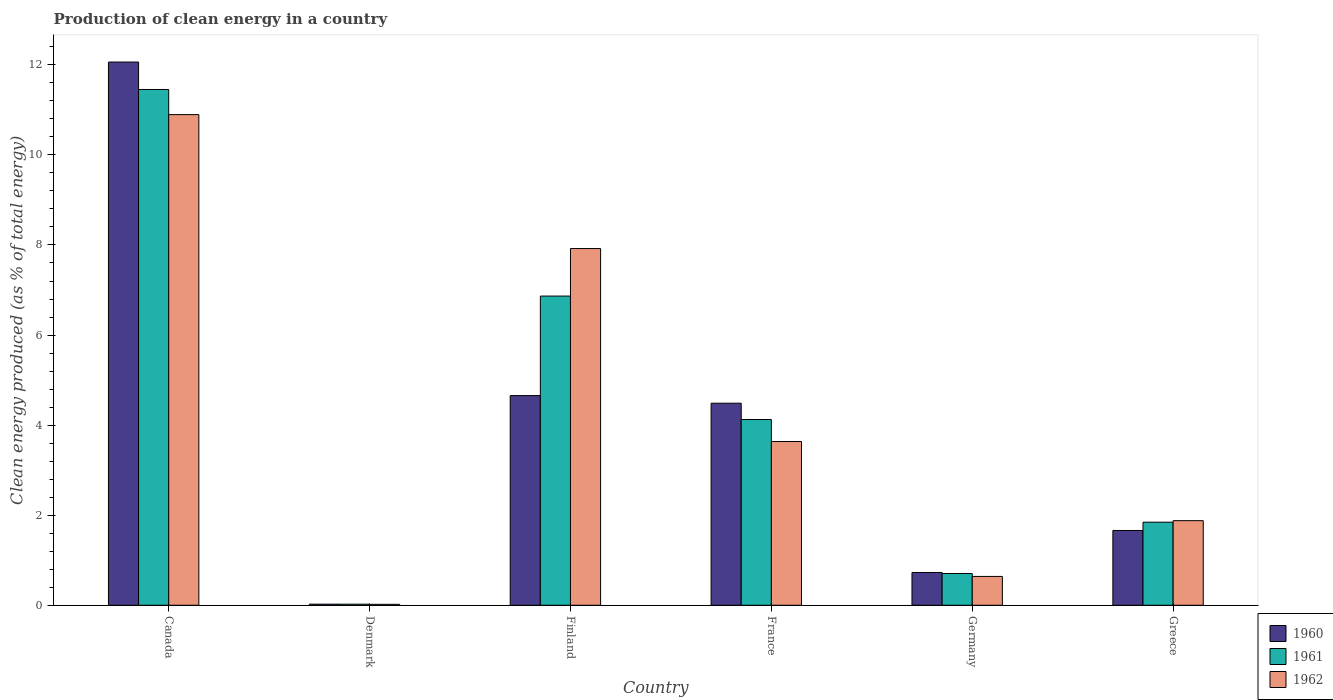How many groups of bars are there?
Ensure brevity in your answer.  6. Are the number of bars on each tick of the X-axis equal?
Keep it short and to the point. Yes. How many bars are there on the 3rd tick from the left?
Provide a short and direct response. 3. What is the percentage of clean energy produced in 1960 in Greece?
Make the answer very short. 1.66. Across all countries, what is the maximum percentage of clean energy produced in 1960?
Provide a short and direct response. 12.06. Across all countries, what is the minimum percentage of clean energy produced in 1960?
Provide a short and direct response. 0.02. In which country was the percentage of clean energy produced in 1961 maximum?
Your response must be concise. Canada. In which country was the percentage of clean energy produced in 1961 minimum?
Offer a very short reply. Denmark. What is the total percentage of clean energy produced in 1961 in the graph?
Keep it short and to the point. 25.02. What is the difference between the percentage of clean energy produced in 1961 in Canada and that in Finland?
Your answer should be very brief. 4.59. What is the difference between the percentage of clean energy produced in 1961 in France and the percentage of clean energy produced in 1960 in Denmark?
Offer a terse response. 4.1. What is the average percentage of clean energy produced in 1962 per country?
Your answer should be very brief. 4.17. What is the difference between the percentage of clean energy produced of/in 1962 and percentage of clean energy produced of/in 1960 in Finland?
Provide a short and direct response. 3.26. In how many countries, is the percentage of clean energy produced in 1961 greater than 5.2 %?
Provide a succinct answer. 2. What is the ratio of the percentage of clean energy produced in 1962 in Canada to that in Germany?
Provide a succinct answer. 17.02. Is the percentage of clean energy produced in 1961 in France less than that in Germany?
Give a very brief answer. No. Is the difference between the percentage of clean energy produced in 1962 in France and Greece greater than the difference between the percentage of clean energy produced in 1960 in France and Greece?
Offer a very short reply. No. What is the difference between the highest and the second highest percentage of clean energy produced in 1962?
Your response must be concise. 7.26. What is the difference between the highest and the lowest percentage of clean energy produced in 1960?
Your response must be concise. 12.04. In how many countries, is the percentage of clean energy produced in 1962 greater than the average percentage of clean energy produced in 1962 taken over all countries?
Provide a succinct answer. 2. Is the sum of the percentage of clean energy produced in 1960 in Canada and Denmark greater than the maximum percentage of clean energy produced in 1962 across all countries?
Your answer should be compact. Yes. Is it the case that in every country, the sum of the percentage of clean energy produced in 1960 and percentage of clean energy produced in 1961 is greater than the percentage of clean energy produced in 1962?
Ensure brevity in your answer.  Yes. Are all the bars in the graph horizontal?
Keep it short and to the point. No. What is the difference between two consecutive major ticks on the Y-axis?
Offer a very short reply. 2. Are the values on the major ticks of Y-axis written in scientific E-notation?
Provide a succinct answer. No. Does the graph contain grids?
Offer a very short reply. No. How many legend labels are there?
Give a very brief answer. 3. What is the title of the graph?
Make the answer very short. Production of clean energy in a country. Does "1976" appear as one of the legend labels in the graph?
Provide a succinct answer. No. What is the label or title of the X-axis?
Ensure brevity in your answer.  Country. What is the label or title of the Y-axis?
Offer a very short reply. Clean energy produced (as % of total energy). What is the Clean energy produced (as % of total energy) in 1960 in Canada?
Your response must be concise. 12.06. What is the Clean energy produced (as % of total energy) in 1961 in Canada?
Your answer should be compact. 11.45. What is the Clean energy produced (as % of total energy) of 1962 in Canada?
Provide a succinct answer. 10.89. What is the Clean energy produced (as % of total energy) of 1960 in Denmark?
Provide a succinct answer. 0.02. What is the Clean energy produced (as % of total energy) of 1961 in Denmark?
Give a very brief answer. 0.02. What is the Clean energy produced (as % of total energy) in 1962 in Denmark?
Your answer should be compact. 0.02. What is the Clean energy produced (as % of total energy) of 1960 in Finland?
Provide a succinct answer. 4.66. What is the Clean energy produced (as % of total energy) in 1961 in Finland?
Make the answer very short. 6.87. What is the Clean energy produced (as % of total energy) in 1962 in Finland?
Make the answer very short. 7.92. What is the Clean energy produced (as % of total energy) of 1960 in France?
Your answer should be very brief. 4.49. What is the Clean energy produced (as % of total energy) of 1961 in France?
Your answer should be very brief. 4.12. What is the Clean energy produced (as % of total energy) of 1962 in France?
Give a very brief answer. 3.64. What is the Clean energy produced (as % of total energy) of 1960 in Germany?
Keep it short and to the point. 0.73. What is the Clean energy produced (as % of total energy) in 1961 in Germany?
Ensure brevity in your answer.  0.7. What is the Clean energy produced (as % of total energy) of 1962 in Germany?
Offer a terse response. 0.64. What is the Clean energy produced (as % of total energy) in 1960 in Greece?
Your response must be concise. 1.66. What is the Clean energy produced (as % of total energy) of 1961 in Greece?
Your response must be concise. 1.84. What is the Clean energy produced (as % of total energy) of 1962 in Greece?
Your answer should be compact. 1.88. Across all countries, what is the maximum Clean energy produced (as % of total energy) of 1960?
Provide a short and direct response. 12.06. Across all countries, what is the maximum Clean energy produced (as % of total energy) of 1961?
Keep it short and to the point. 11.45. Across all countries, what is the maximum Clean energy produced (as % of total energy) of 1962?
Offer a terse response. 10.89. Across all countries, what is the minimum Clean energy produced (as % of total energy) of 1960?
Your answer should be compact. 0.02. Across all countries, what is the minimum Clean energy produced (as % of total energy) of 1961?
Keep it short and to the point. 0.02. Across all countries, what is the minimum Clean energy produced (as % of total energy) in 1962?
Provide a short and direct response. 0.02. What is the total Clean energy produced (as % of total energy) of 1960 in the graph?
Make the answer very short. 23.62. What is the total Clean energy produced (as % of total energy) of 1961 in the graph?
Provide a short and direct response. 25.02. What is the total Clean energy produced (as % of total energy) in 1962 in the graph?
Your response must be concise. 24.99. What is the difference between the Clean energy produced (as % of total energy) in 1960 in Canada and that in Denmark?
Keep it short and to the point. 12.04. What is the difference between the Clean energy produced (as % of total energy) in 1961 in Canada and that in Denmark?
Make the answer very short. 11.43. What is the difference between the Clean energy produced (as % of total energy) of 1962 in Canada and that in Denmark?
Make the answer very short. 10.87. What is the difference between the Clean energy produced (as % of total energy) in 1960 in Canada and that in Finland?
Provide a succinct answer. 7.41. What is the difference between the Clean energy produced (as % of total energy) in 1961 in Canada and that in Finland?
Make the answer very short. 4.59. What is the difference between the Clean energy produced (as % of total energy) in 1962 in Canada and that in Finland?
Your answer should be compact. 2.97. What is the difference between the Clean energy produced (as % of total energy) of 1960 in Canada and that in France?
Your response must be concise. 7.58. What is the difference between the Clean energy produced (as % of total energy) of 1961 in Canada and that in France?
Offer a terse response. 7.33. What is the difference between the Clean energy produced (as % of total energy) in 1962 in Canada and that in France?
Your answer should be compact. 7.26. What is the difference between the Clean energy produced (as % of total energy) of 1960 in Canada and that in Germany?
Give a very brief answer. 11.33. What is the difference between the Clean energy produced (as % of total energy) in 1961 in Canada and that in Germany?
Give a very brief answer. 10.75. What is the difference between the Clean energy produced (as % of total energy) in 1962 in Canada and that in Germany?
Provide a short and direct response. 10.25. What is the difference between the Clean energy produced (as % of total energy) of 1960 in Canada and that in Greece?
Keep it short and to the point. 10.4. What is the difference between the Clean energy produced (as % of total energy) in 1961 in Canada and that in Greece?
Provide a short and direct response. 9.61. What is the difference between the Clean energy produced (as % of total energy) of 1962 in Canada and that in Greece?
Give a very brief answer. 9.02. What is the difference between the Clean energy produced (as % of total energy) in 1960 in Denmark and that in Finland?
Your answer should be very brief. -4.63. What is the difference between the Clean energy produced (as % of total energy) of 1961 in Denmark and that in Finland?
Ensure brevity in your answer.  -6.84. What is the difference between the Clean energy produced (as % of total energy) of 1962 in Denmark and that in Finland?
Your response must be concise. -7.9. What is the difference between the Clean energy produced (as % of total energy) of 1960 in Denmark and that in France?
Keep it short and to the point. -4.46. What is the difference between the Clean energy produced (as % of total energy) of 1961 in Denmark and that in France?
Keep it short and to the point. -4.1. What is the difference between the Clean energy produced (as % of total energy) of 1962 in Denmark and that in France?
Give a very brief answer. -3.62. What is the difference between the Clean energy produced (as % of total energy) of 1960 in Denmark and that in Germany?
Your answer should be very brief. -0.7. What is the difference between the Clean energy produced (as % of total energy) in 1961 in Denmark and that in Germany?
Ensure brevity in your answer.  -0.68. What is the difference between the Clean energy produced (as % of total energy) in 1962 in Denmark and that in Germany?
Provide a short and direct response. -0.62. What is the difference between the Clean energy produced (as % of total energy) in 1960 in Denmark and that in Greece?
Your answer should be very brief. -1.64. What is the difference between the Clean energy produced (as % of total energy) in 1961 in Denmark and that in Greece?
Keep it short and to the point. -1.82. What is the difference between the Clean energy produced (as % of total energy) of 1962 in Denmark and that in Greece?
Your answer should be very brief. -1.86. What is the difference between the Clean energy produced (as % of total energy) in 1960 in Finland and that in France?
Your response must be concise. 0.17. What is the difference between the Clean energy produced (as % of total energy) of 1961 in Finland and that in France?
Give a very brief answer. 2.74. What is the difference between the Clean energy produced (as % of total energy) in 1962 in Finland and that in France?
Provide a succinct answer. 4.28. What is the difference between the Clean energy produced (as % of total energy) in 1960 in Finland and that in Germany?
Offer a very short reply. 3.93. What is the difference between the Clean energy produced (as % of total energy) in 1961 in Finland and that in Germany?
Offer a terse response. 6.16. What is the difference between the Clean energy produced (as % of total energy) of 1962 in Finland and that in Germany?
Your response must be concise. 7.28. What is the difference between the Clean energy produced (as % of total energy) in 1960 in Finland and that in Greece?
Your response must be concise. 3. What is the difference between the Clean energy produced (as % of total energy) of 1961 in Finland and that in Greece?
Provide a short and direct response. 5.02. What is the difference between the Clean energy produced (as % of total energy) of 1962 in Finland and that in Greece?
Your response must be concise. 6.04. What is the difference between the Clean energy produced (as % of total energy) of 1960 in France and that in Germany?
Provide a succinct answer. 3.76. What is the difference between the Clean energy produced (as % of total energy) in 1961 in France and that in Germany?
Make the answer very short. 3.42. What is the difference between the Clean energy produced (as % of total energy) of 1962 in France and that in Germany?
Ensure brevity in your answer.  3. What is the difference between the Clean energy produced (as % of total energy) of 1960 in France and that in Greece?
Offer a terse response. 2.83. What is the difference between the Clean energy produced (as % of total energy) in 1961 in France and that in Greece?
Provide a succinct answer. 2.28. What is the difference between the Clean energy produced (as % of total energy) in 1962 in France and that in Greece?
Your response must be concise. 1.76. What is the difference between the Clean energy produced (as % of total energy) in 1960 in Germany and that in Greece?
Your answer should be compact. -0.93. What is the difference between the Clean energy produced (as % of total energy) of 1961 in Germany and that in Greece?
Ensure brevity in your answer.  -1.14. What is the difference between the Clean energy produced (as % of total energy) in 1962 in Germany and that in Greece?
Make the answer very short. -1.24. What is the difference between the Clean energy produced (as % of total energy) in 1960 in Canada and the Clean energy produced (as % of total energy) in 1961 in Denmark?
Keep it short and to the point. 12.04. What is the difference between the Clean energy produced (as % of total energy) in 1960 in Canada and the Clean energy produced (as % of total energy) in 1962 in Denmark?
Your answer should be very brief. 12.04. What is the difference between the Clean energy produced (as % of total energy) of 1961 in Canada and the Clean energy produced (as % of total energy) of 1962 in Denmark?
Your answer should be compact. 11.43. What is the difference between the Clean energy produced (as % of total energy) of 1960 in Canada and the Clean energy produced (as % of total energy) of 1961 in Finland?
Make the answer very short. 5.2. What is the difference between the Clean energy produced (as % of total energy) in 1960 in Canada and the Clean energy produced (as % of total energy) in 1962 in Finland?
Offer a terse response. 4.14. What is the difference between the Clean energy produced (as % of total energy) of 1961 in Canada and the Clean energy produced (as % of total energy) of 1962 in Finland?
Keep it short and to the point. 3.53. What is the difference between the Clean energy produced (as % of total energy) in 1960 in Canada and the Clean energy produced (as % of total energy) in 1961 in France?
Ensure brevity in your answer.  7.94. What is the difference between the Clean energy produced (as % of total energy) of 1960 in Canada and the Clean energy produced (as % of total energy) of 1962 in France?
Keep it short and to the point. 8.43. What is the difference between the Clean energy produced (as % of total energy) of 1961 in Canada and the Clean energy produced (as % of total energy) of 1962 in France?
Offer a terse response. 7.82. What is the difference between the Clean energy produced (as % of total energy) in 1960 in Canada and the Clean energy produced (as % of total energy) in 1961 in Germany?
Offer a terse response. 11.36. What is the difference between the Clean energy produced (as % of total energy) in 1960 in Canada and the Clean energy produced (as % of total energy) in 1962 in Germany?
Your answer should be compact. 11.42. What is the difference between the Clean energy produced (as % of total energy) in 1961 in Canada and the Clean energy produced (as % of total energy) in 1962 in Germany?
Keep it short and to the point. 10.81. What is the difference between the Clean energy produced (as % of total energy) of 1960 in Canada and the Clean energy produced (as % of total energy) of 1961 in Greece?
Provide a succinct answer. 10.22. What is the difference between the Clean energy produced (as % of total energy) in 1960 in Canada and the Clean energy produced (as % of total energy) in 1962 in Greece?
Your answer should be compact. 10.18. What is the difference between the Clean energy produced (as % of total energy) of 1961 in Canada and the Clean energy produced (as % of total energy) of 1962 in Greece?
Ensure brevity in your answer.  9.57. What is the difference between the Clean energy produced (as % of total energy) in 1960 in Denmark and the Clean energy produced (as % of total energy) in 1961 in Finland?
Give a very brief answer. -6.84. What is the difference between the Clean energy produced (as % of total energy) of 1960 in Denmark and the Clean energy produced (as % of total energy) of 1962 in Finland?
Your answer should be compact. -7.9. What is the difference between the Clean energy produced (as % of total energy) in 1961 in Denmark and the Clean energy produced (as % of total energy) in 1962 in Finland?
Your answer should be compact. -7.9. What is the difference between the Clean energy produced (as % of total energy) in 1960 in Denmark and the Clean energy produced (as % of total energy) in 1962 in France?
Give a very brief answer. -3.61. What is the difference between the Clean energy produced (as % of total energy) of 1961 in Denmark and the Clean energy produced (as % of total energy) of 1962 in France?
Offer a very short reply. -3.61. What is the difference between the Clean energy produced (as % of total energy) in 1960 in Denmark and the Clean energy produced (as % of total energy) in 1961 in Germany?
Offer a terse response. -0.68. What is the difference between the Clean energy produced (as % of total energy) in 1960 in Denmark and the Clean energy produced (as % of total energy) in 1962 in Germany?
Your answer should be very brief. -0.62. What is the difference between the Clean energy produced (as % of total energy) of 1961 in Denmark and the Clean energy produced (as % of total energy) of 1962 in Germany?
Provide a succinct answer. -0.62. What is the difference between the Clean energy produced (as % of total energy) in 1960 in Denmark and the Clean energy produced (as % of total energy) in 1961 in Greece?
Ensure brevity in your answer.  -1.82. What is the difference between the Clean energy produced (as % of total energy) in 1960 in Denmark and the Clean energy produced (as % of total energy) in 1962 in Greece?
Keep it short and to the point. -1.85. What is the difference between the Clean energy produced (as % of total energy) in 1961 in Denmark and the Clean energy produced (as % of total energy) in 1962 in Greece?
Keep it short and to the point. -1.85. What is the difference between the Clean energy produced (as % of total energy) in 1960 in Finland and the Clean energy produced (as % of total energy) in 1961 in France?
Your answer should be very brief. 0.53. What is the difference between the Clean energy produced (as % of total energy) in 1960 in Finland and the Clean energy produced (as % of total energy) in 1962 in France?
Your answer should be compact. 1.02. What is the difference between the Clean energy produced (as % of total energy) of 1961 in Finland and the Clean energy produced (as % of total energy) of 1962 in France?
Your answer should be compact. 3.23. What is the difference between the Clean energy produced (as % of total energy) in 1960 in Finland and the Clean energy produced (as % of total energy) in 1961 in Germany?
Keep it short and to the point. 3.95. What is the difference between the Clean energy produced (as % of total energy) of 1960 in Finland and the Clean energy produced (as % of total energy) of 1962 in Germany?
Provide a succinct answer. 4.02. What is the difference between the Clean energy produced (as % of total energy) of 1961 in Finland and the Clean energy produced (as % of total energy) of 1962 in Germany?
Your answer should be compact. 6.23. What is the difference between the Clean energy produced (as % of total energy) of 1960 in Finland and the Clean energy produced (as % of total energy) of 1961 in Greece?
Offer a terse response. 2.81. What is the difference between the Clean energy produced (as % of total energy) in 1960 in Finland and the Clean energy produced (as % of total energy) in 1962 in Greece?
Provide a succinct answer. 2.78. What is the difference between the Clean energy produced (as % of total energy) of 1961 in Finland and the Clean energy produced (as % of total energy) of 1962 in Greece?
Your answer should be compact. 4.99. What is the difference between the Clean energy produced (as % of total energy) of 1960 in France and the Clean energy produced (as % of total energy) of 1961 in Germany?
Provide a short and direct response. 3.78. What is the difference between the Clean energy produced (as % of total energy) in 1960 in France and the Clean energy produced (as % of total energy) in 1962 in Germany?
Offer a very short reply. 3.85. What is the difference between the Clean energy produced (as % of total energy) in 1961 in France and the Clean energy produced (as % of total energy) in 1962 in Germany?
Your response must be concise. 3.48. What is the difference between the Clean energy produced (as % of total energy) of 1960 in France and the Clean energy produced (as % of total energy) of 1961 in Greece?
Provide a short and direct response. 2.64. What is the difference between the Clean energy produced (as % of total energy) in 1960 in France and the Clean energy produced (as % of total energy) in 1962 in Greece?
Give a very brief answer. 2.61. What is the difference between the Clean energy produced (as % of total energy) in 1961 in France and the Clean energy produced (as % of total energy) in 1962 in Greece?
Your answer should be very brief. 2.25. What is the difference between the Clean energy produced (as % of total energy) in 1960 in Germany and the Clean energy produced (as % of total energy) in 1961 in Greece?
Provide a short and direct response. -1.12. What is the difference between the Clean energy produced (as % of total energy) of 1960 in Germany and the Clean energy produced (as % of total energy) of 1962 in Greece?
Make the answer very short. -1.15. What is the difference between the Clean energy produced (as % of total energy) in 1961 in Germany and the Clean energy produced (as % of total energy) in 1962 in Greece?
Your answer should be compact. -1.17. What is the average Clean energy produced (as % of total energy) of 1960 per country?
Make the answer very short. 3.94. What is the average Clean energy produced (as % of total energy) of 1961 per country?
Keep it short and to the point. 4.17. What is the average Clean energy produced (as % of total energy) in 1962 per country?
Provide a succinct answer. 4.17. What is the difference between the Clean energy produced (as % of total energy) of 1960 and Clean energy produced (as % of total energy) of 1961 in Canada?
Your answer should be very brief. 0.61. What is the difference between the Clean energy produced (as % of total energy) of 1960 and Clean energy produced (as % of total energy) of 1962 in Canada?
Keep it short and to the point. 1.17. What is the difference between the Clean energy produced (as % of total energy) in 1961 and Clean energy produced (as % of total energy) in 1962 in Canada?
Make the answer very short. 0.56. What is the difference between the Clean energy produced (as % of total energy) in 1960 and Clean energy produced (as % of total energy) in 1962 in Denmark?
Make the answer very short. 0. What is the difference between the Clean energy produced (as % of total energy) of 1961 and Clean energy produced (as % of total energy) of 1962 in Denmark?
Your response must be concise. 0. What is the difference between the Clean energy produced (as % of total energy) in 1960 and Clean energy produced (as % of total energy) in 1961 in Finland?
Your answer should be very brief. -2.21. What is the difference between the Clean energy produced (as % of total energy) of 1960 and Clean energy produced (as % of total energy) of 1962 in Finland?
Your answer should be very brief. -3.26. What is the difference between the Clean energy produced (as % of total energy) of 1961 and Clean energy produced (as % of total energy) of 1962 in Finland?
Provide a succinct answer. -1.06. What is the difference between the Clean energy produced (as % of total energy) in 1960 and Clean energy produced (as % of total energy) in 1961 in France?
Keep it short and to the point. 0.36. What is the difference between the Clean energy produced (as % of total energy) of 1960 and Clean energy produced (as % of total energy) of 1962 in France?
Keep it short and to the point. 0.85. What is the difference between the Clean energy produced (as % of total energy) of 1961 and Clean energy produced (as % of total energy) of 1962 in France?
Keep it short and to the point. 0.49. What is the difference between the Clean energy produced (as % of total energy) of 1960 and Clean energy produced (as % of total energy) of 1961 in Germany?
Ensure brevity in your answer.  0.02. What is the difference between the Clean energy produced (as % of total energy) in 1960 and Clean energy produced (as % of total energy) in 1962 in Germany?
Offer a very short reply. 0.09. What is the difference between the Clean energy produced (as % of total energy) of 1961 and Clean energy produced (as % of total energy) of 1962 in Germany?
Your answer should be very brief. 0.06. What is the difference between the Clean energy produced (as % of total energy) in 1960 and Clean energy produced (as % of total energy) in 1961 in Greece?
Your answer should be compact. -0.18. What is the difference between the Clean energy produced (as % of total energy) of 1960 and Clean energy produced (as % of total energy) of 1962 in Greece?
Your response must be concise. -0.22. What is the difference between the Clean energy produced (as % of total energy) of 1961 and Clean energy produced (as % of total energy) of 1962 in Greece?
Keep it short and to the point. -0.03. What is the ratio of the Clean energy produced (as % of total energy) of 1960 in Canada to that in Denmark?
Your answer should be compact. 494.07. What is the ratio of the Clean energy produced (as % of total energy) of 1961 in Canada to that in Denmark?
Offer a terse response. 477.92. What is the ratio of the Clean energy produced (as % of total energy) of 1962 in Canada to that in Denmark?
Ensure brevity in your answer.  520.01. What is the ratio of the Clean energy produced (as % of total energy) of 1960 in Canada to that in Finland?
Your answer should be very brief. 2.59. What is the ratio of the Clean energy produced (as % of total energy) of 1961 in Canada to that in Finland?
Your answer should be very brief. 1.67. What is the ratio of the Clean energy produced (as % of total energy) in 1962 in Canada to that in Finland?
Ensure brevity in your answer.  1.38. What is the ratio of the Clean energy produced (as % of total energy) of 1960 in Canada to that in France?
Your response must be concise. 2.69. What is the ratio of the Clean energy produced (as % of total energy) in 1961 in Canada to that in France?
Your answer should be very brief. 2.78. What is the ratio of the Clean energy produced (as % of total energy) in 1962 in Canada to that in France?
Ensure brevity in your answer.  3. What is the ratio of the Clean energy produced (as % of total energy) of 1960 in Canada to that in Germany?
Your answer should be very brief. 16.57. What is the ratio of the Clean energy produced (as % of total energy) in 1961 in Canada to that in Germany?
Provide a short and direct response. 16.25. What is the ratio of the Clean energy produced (as % of total energy) of 1962 in Canada to that in Germany?
Provide a succinct answer. 17.02. What is the ratio of the Clean energy produced (as % of total energy) of 1960 in Canada to that in Greece?
Offer a terse response. 7.26. What is the ratio of the Clean energy produced (as % of total energy) of 1961 in Canada to that in Greece?
Keep it short and to the point. 6.21. What is the ratio of the Clean energy produced (as % of total energy) of 1962 in Canada to that in Greece?
Keep it short and to the point. 5.8. What is the ratio of the Clean energy produced (as % of total energy) of 1960 in Denmark to that in Finland?
Your response must be concise. 0.01. What is the ratio of the Clean energy produced (as % of total energy) in 1961 in Denmark to that in Finland?
Offer a terse response. 0. What is the ratio of the Clean energy produced (as % of total energy) in 1962 in Denmark to that in Finland?
Ensure brevity in your answer.  0. What is the ratio of the Clean energy produced (as % of total energy) in 1960 in Denmark to that in France?
Give a very brief answer. 0.01. What is the ratio of the Clean energy produced (as % of total energy) of 1961 in Denmark to that in France?
Your response must be concise. 0.01. What is the ratio of the Clean energy produced (as % of total energy) of 1962 in Denmark to that in France?
Offer a terse response. 0.01. What is the ratio of the Clean energy produced (as % of total energy) of 1960 in Denmark to that in Germany?
Make the answer very short. 0.03. What is the ratio of the Clean energy produced (as % of total energy) in 1961 in Denmark to that in Germany?
Make the answer very short. 0.03. What is the ratio of the Clean energy produced (as % of total energy) in 1962 in Denmark to that in Germany?
Provide a succinct answer. 0.03. What is the ratio of the Clean energy produced (as % of total energy) of 1960 in Denmark to that in Greece?
Provide a succinct answer. 0.01. What is the ratio of the Clean energy produced (as % of total energy) of 1961 in Denmark to that in Greece?
Offer a terse response. 0.01. What is the ratio of the Clean energy produced (as % of total energy) of 1962 in Denmark to that in Greece?
Offer a terse response. 0.01. What is the ratio of the Clean energy produced (as % of total energy) of 1960 in Finland to that in France?
Provide a short and direct response. 1.04. What is the ratio of the Clean energy produced (as % of total energy) in 1961 in Finland to that in France?
Offer a very short reply. 1.66. What is the ratio of the Clean energy produced (as % of total energy) in 1962 in Finland to that in France?
Ensure brevity in your answer.  2.18. What is the ratio of the Clean energy produced (as % of total energy) in 1960 in Finland to that in Germany?
Offer a terse response. 6.4. What is the ratio of the Clean energy produced (as % of total energy) of 1961 in Finland to that in Germany?
Offer a very short reply. 9.74. What is the ratio of the Clean energy produced (as % of total energy) in 1962 in Finland to that in Germany?
Your response must be concise. 12.37. What is the ratio of the Clean energy produced (as % of total energy) of 1960 in Finland to that in Greece?
Ensure brevity in your answer.  2.8. What is the ratio of the Clean energy produced (as % of total energy) in 1961 in Finland to that in Greece?
Your response must be concise. 3.72. What is the ratio of the Clean energy produced (as % of total energy) of 1962 in Finland to that in Greece?
Your answer should be very brief. 4.22. What is the ratio of the Clean energy produced (as % of total energy) of 1960 in France to that in Germany?
Keep it short and to the point. 6.16. What is the ratio of the Clean energy produced (as % of total energy) of 1961 in France to that in Germany?
Provide a short and direct response. 5.85. What is the ratio of the Clean energy produced (as % of total energy) of 1962 in France to that in Germany?
Offer a terse response. 5.68. What is the ratio of the Clean energy produced (as % of total energy) of 1960 in France to that in Greece?
Ensure brevity in your answer.  2.7. What is the ratio of the Clean energy produced (as % of total energy) of 1961 in France to that in Greece?
Provide a succinct answer. 2.24. What is the ratio of the Clean energy produced (as % of total energy) in 1962 in France to that in Greece?
Your answer should be very brief. 1.94. What is the ratio of the Clean energy produced (as % of total energy) of 1960 in Germany to that in Greece?
Ensure brevity in your answer.  0.44. What is the ratio of the Clean energy produced (as % of total energy) in 1961 in Germany to that in Greece?
Ensure brevity in your answer.  0.38. What is the ratio of the Clean energy produced (as % of total energy) of 1962 in Germany to that in Greece?
Provide a succinct answer. 0.34. What is the difference between the highest and the second highest Clean energy produced (as % of total energy) of 1960?
Offer a terse response. 7.41. What is the difference between the highest and the second highest Clean energy produced (as % of total energy) in 1961?
Keep it short and to the point. 4.59. What is the difference between the highest and the second highest Clean energy produced (as % of total energy) in 1962?
Give a very brief answer. 2.97. What is the difference between the highest and the lowest Clean energy produced (as % of total energy) of 1960?
Provide a succinct answer. 12.04. What is the difference between the highest and the lowest Clean energy produced (as % of total energy) of 1961?
Your answer should be compact. 11.43. What is the difference between the highest and the lowest Clean energy produced (as % of total energy) in 1962?
Your response must be concise. 10.87. 